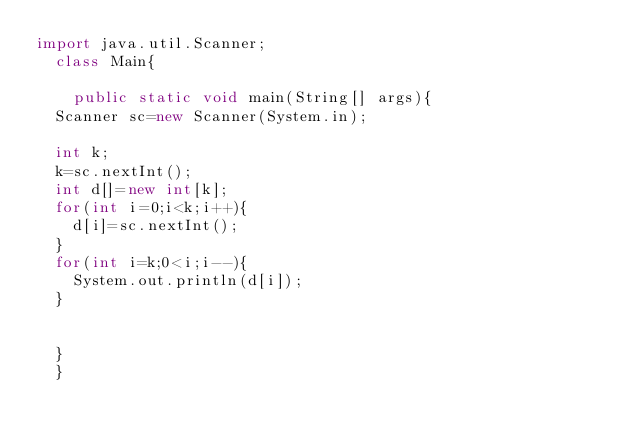Convert code to text. <code><loc_0><loc_0><loc_500><loc_500><_Java_>import java.util.Scanner;
	class Main{

		public static void main(String[] args){
	Scanner sc=new Scanner(System.in);

	int k;
	k=sc.nextInt();
	int d[]=new int[k];
	for(int i=0;i<k;i++){
		d[i]=sc.nextInt();
	}
	for(int i=k;0<i;i--){
		System.out.println(d[i]);
	}
	
	
	}
	}</code> 